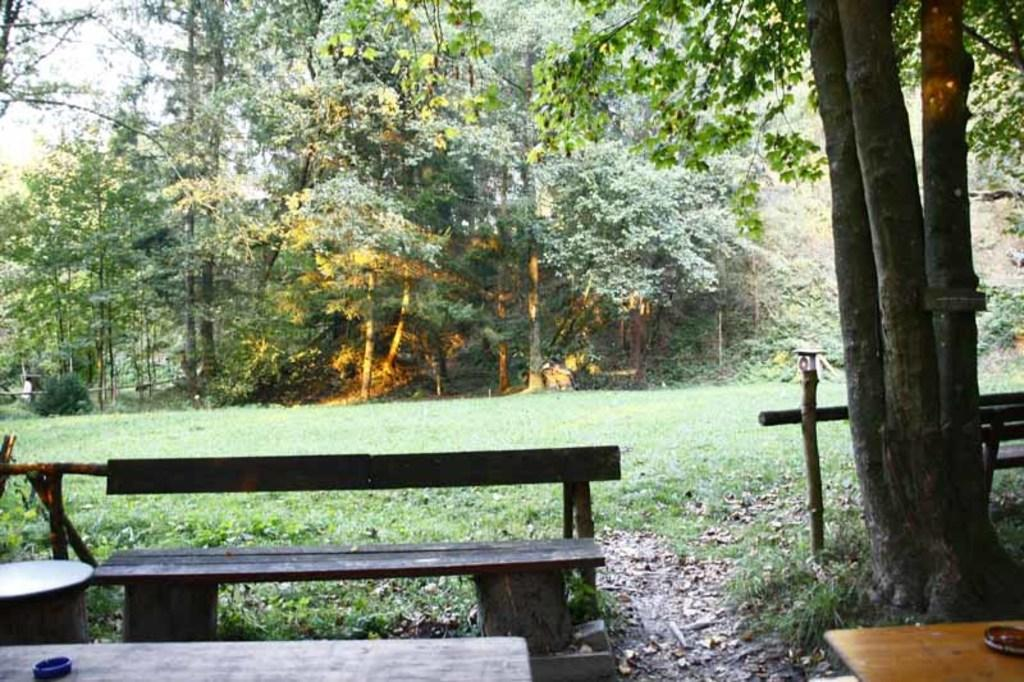What type of seating is visible in the image? There are benches in the image. What else can be seen in the image besides the benches? There are tables and trees visible in the image. What is the ground covered with in the image? There is green grass in the image. How many feet does the uncle have in the image? There is no uncle present in the image, so it is not possible to determine how many feet he might have. 